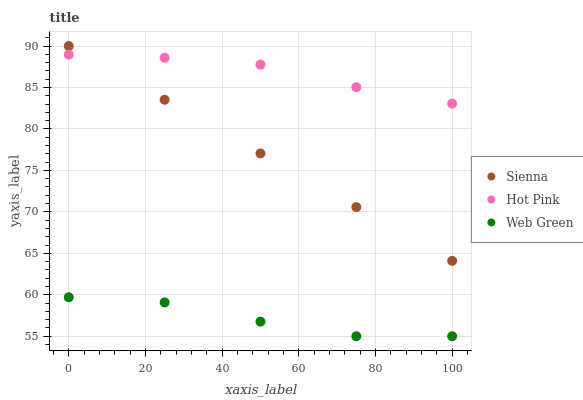Does Web Green have the minimum area under the curve?
Answer yes or no. Yes. Does Hot Pink have the maximum area under the curve?
Answer yes or no. Yes. Does Hot Pink have the minimum area under the curve?
Answer yes or no. No. Does Web Green have the maximum area under the curve?
Answer yes or no. No. Is Sienna the smoothest?
Answer yes or no. Yes. Is Web Green the roughest?
Answer yes or no. Yes. Is Hot Pink the smoothest?
Answer yes or no. No. Is Hot Pink the roughest?
Answer yes or no. No. Does Web Green have the lowest value?
Answer yes or no. Yes. Does Hot Pink have the lowest value?
Answer yes or no. No. Does Sienna have the highest value?
Answer yes or no. Yes. Does Hot Pink have the highest value?
Answer yes or no. No. Is Web Green less than Sienna?
Answer yes or no. Yes. Is Hot Pink greater than Web Green?
Answer yes or no. Yes. Does Hot Pink intersect Sienna?
Answer yes or no. Yes. Is Hot Pink less than Sienna?
Answer yes or no. No. Is Hot Pink greater than Sienna?
Answer yes or no. No. Does Web Green intersect Sienna?
Answer yes or no. No. 